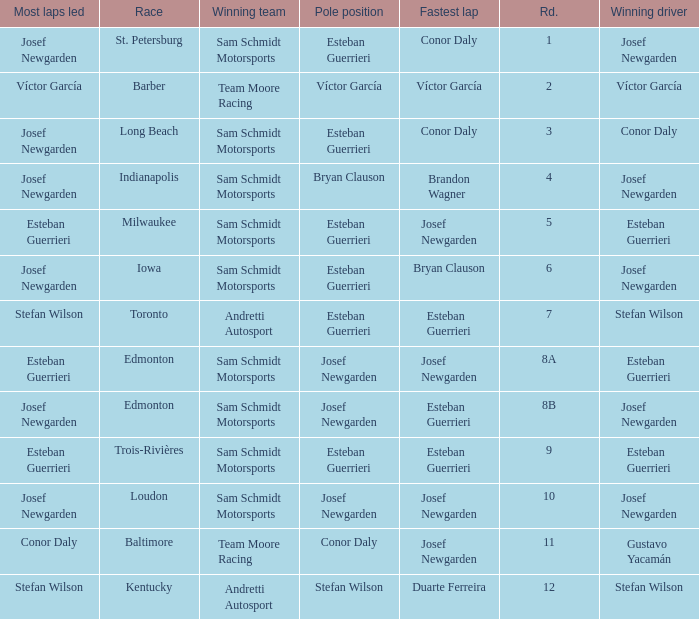Who had the fastest lap(s) when josef newgarden led the most laps at edmonton? Esteban Guerrieri. 